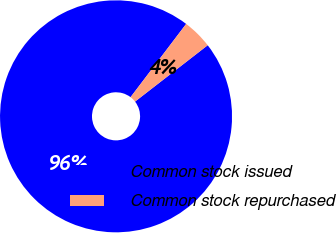Convert chart. <chart><loc_0><loc_0><loc_500><loc_500><pie_chart><fcel>Common stock issued<fcel>Common stock repurchased<nl><fcel>95.83%<fcel>4.17%<nl></chart> 